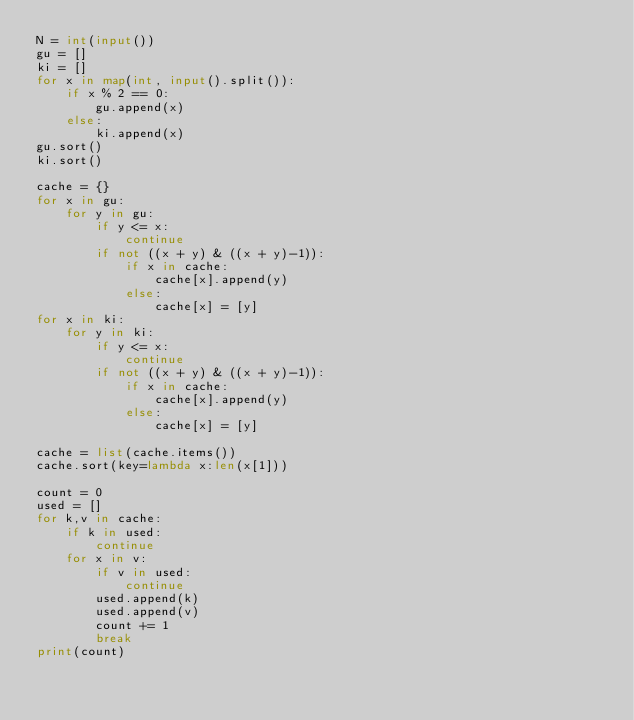<code> <loc_0><loc_0><loc_500><loc_500><_Python_>N = int(input())
gu = []
ki = []
for x in map(int, input().split()):
    if x % 2 == 0:
        gu.append(x)
    else:
        ki.append(x)
gu.sort()
ki.sort()

cache = {}
for x in gu:
    for y in gu:
        if y <= x:
            continue
        if not ((x + y) & ((x + y)-1)):
            if x in cache:
                cache[x].append(y)
            else:
                cache[x] = [y]
for x in ki:
    for y in ki:
        if y <= x:
            continue
        if not ((x + y) & ((x + y)-1)):
            if x in cache:
                cache[x].append(y)
            else:
                cache[x] = [y]

cache = list(cache.items())
cache.sort(key=lambda x:len(x[1]))

count = 0
used = []
for k,v in cache:
    if k in used:
        continue
    for x in v:
        if v in used:
            continue
        used.append(k)
        used.append(v)
        count += 1
        break
print(count)</code> 